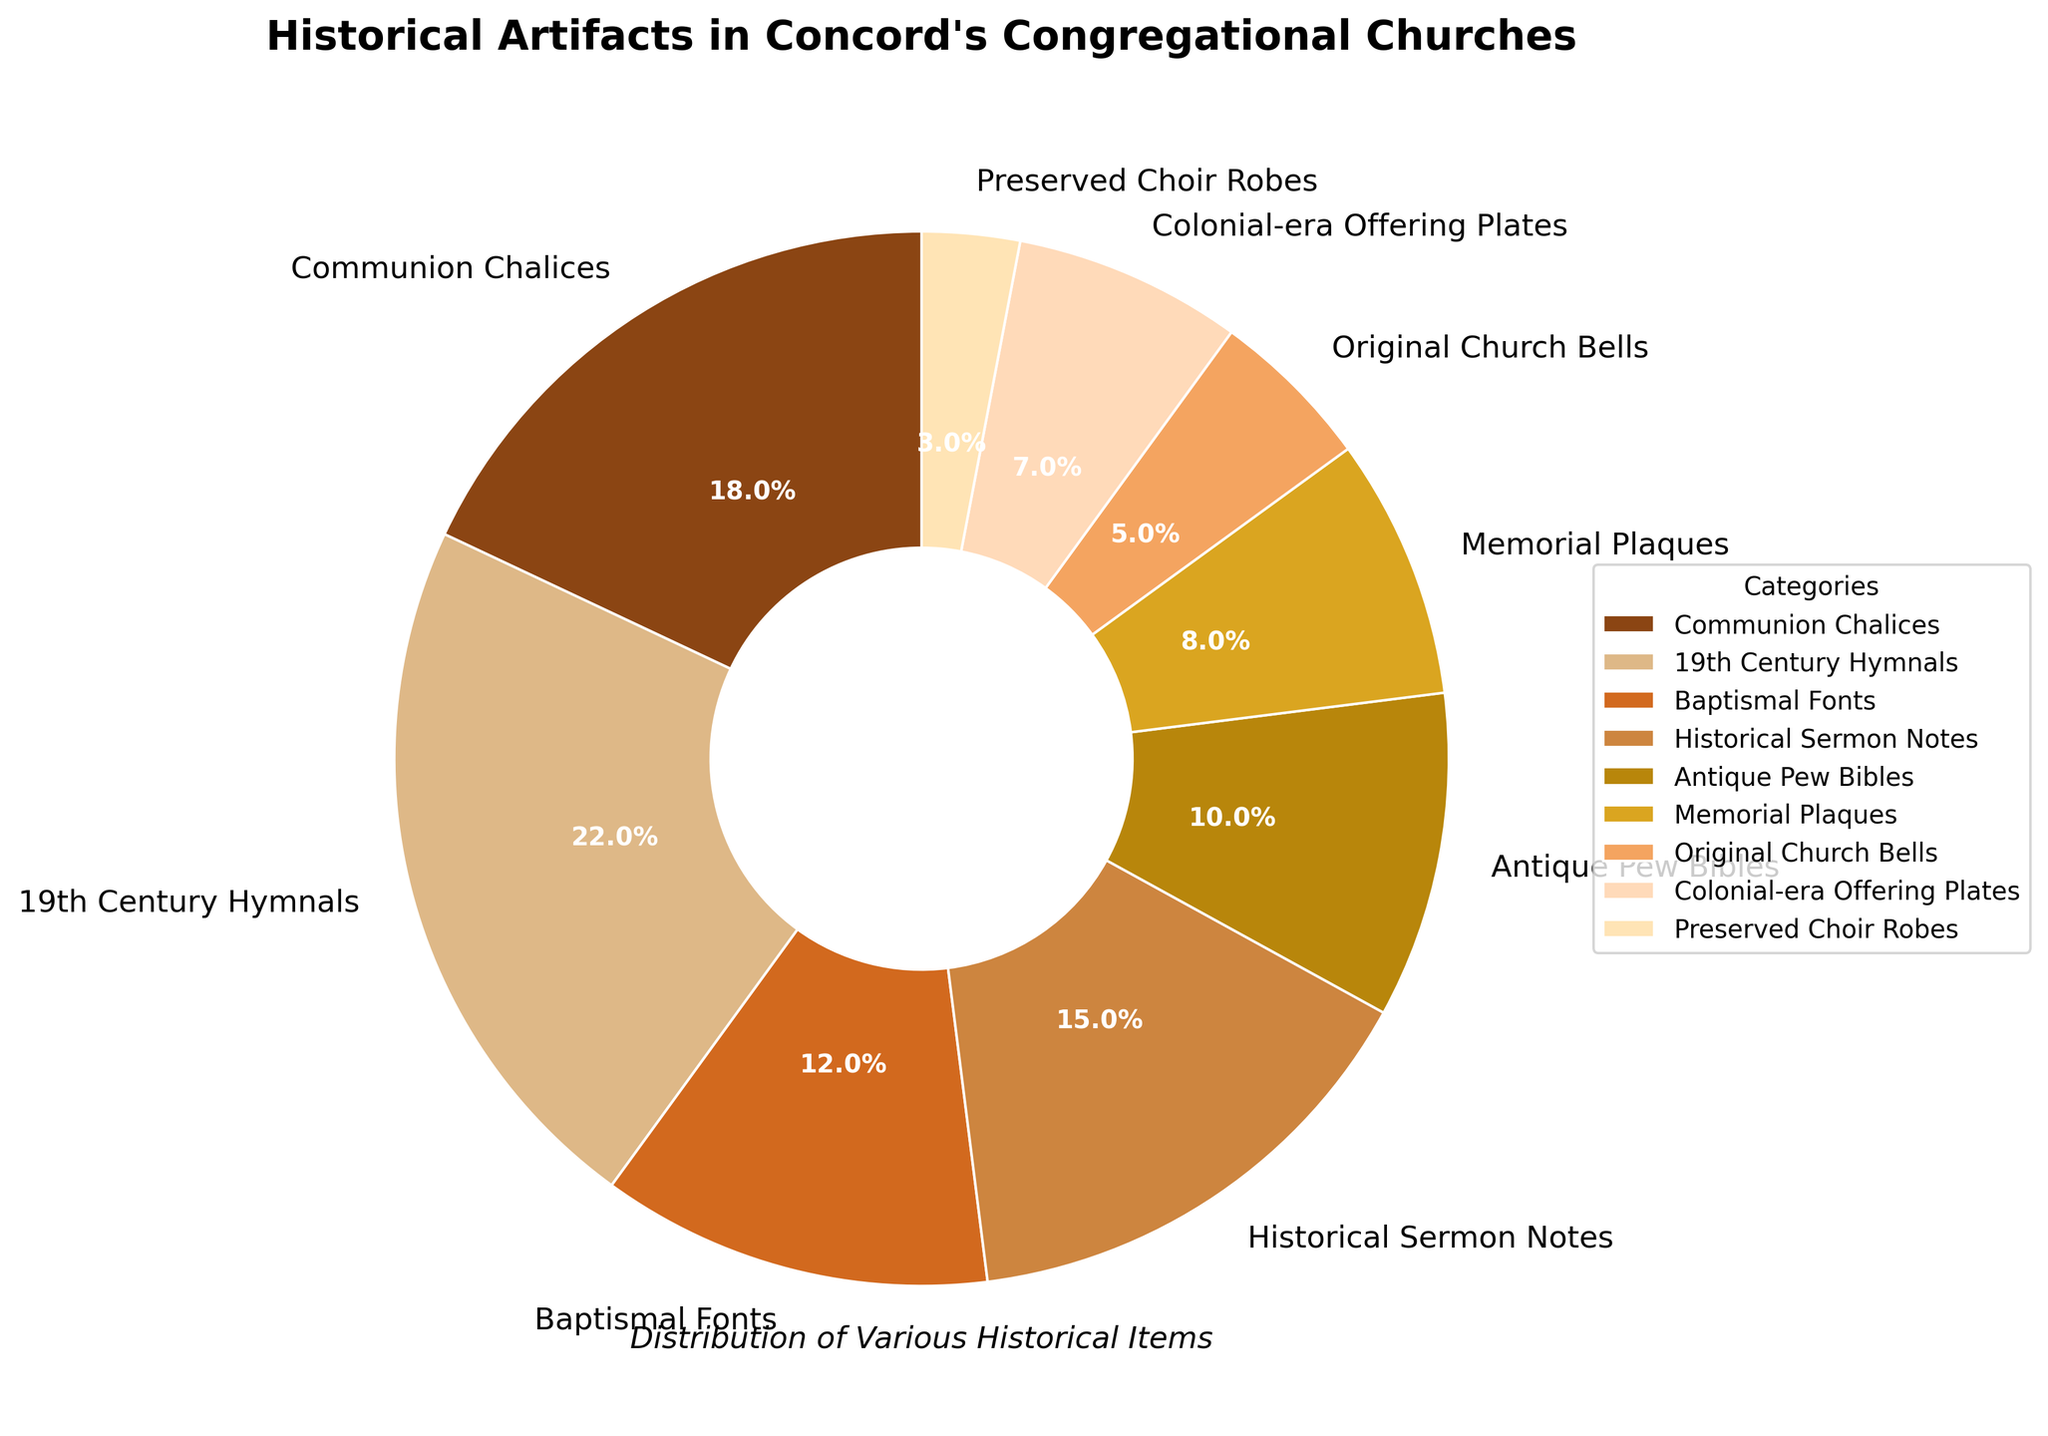which category has the largest proportion of historical artifacts? According to the pie chart, the 19th Century Hymnals category has the largest proportion of historical artifacts with 22%.
Answer: 19th Century Hymnals what is the combined percentage of Historical Sermon Notes and Antique Pew Bibles? The percentage for Historical Sermon Notes is 15%, and the percentage for Antique Pew Bibles is 10%. Adding them together gives 15% + 10% = 25%.
Answer: 25% which artifact category comprises less than 10% but more than 5% of the total? According to the chart, Colonial-era Offering Plates make up 7% of the total, which is less than 10% but more than 5%.
Answer: Colonial-era Offering Plates which artifact has the smallest proportion in the pie chart and what is its percentage? The category with the smallest proportion is Preserved Choir Robes, which accounts for 3% of the total.
Answer: Preserved Choir Robes, 3% are there more Memorial Plaques or Baptismal Fonts? By how much? Memorial Plaques account for 8% and Baptismal Fonts account for 12%. The difference is 12% - 8% = 4%. Therefore, there are 4% more Baptismal Fonts than Memorial Plaques.
Answer: Baptismal Fonts by 4% what is the combined proportion of artifacts that are below 10% each? The categories below 10% are Antique Pew Bibles (10%), Memorial Plaques (8%), Original Church Bells (5%), Colonial-era Offering Plates (7%), and Preserved Choir Robes (3%). Summing these amounts gives 10% + 8% + 5% + 7% + 3% = 33%.
Answer: 33% how much larger is the percentage of 19th Century Hymnals compared to Original Church Bells? 19th Century Hymnals make up 22% and Original Church Bells make up 5%. Calculating the difference: 22% - 5% = 17%.
Answer: 17% which categories have a combined percentage equal to the percentage of 19th Century Hymnals? The categories that add up to 22% include Communion Chalices (18%) and Preserved Choir Robes (3%) plus rounding error (1%).
Answer: Communion Chalices and Preserved Choir Robes 